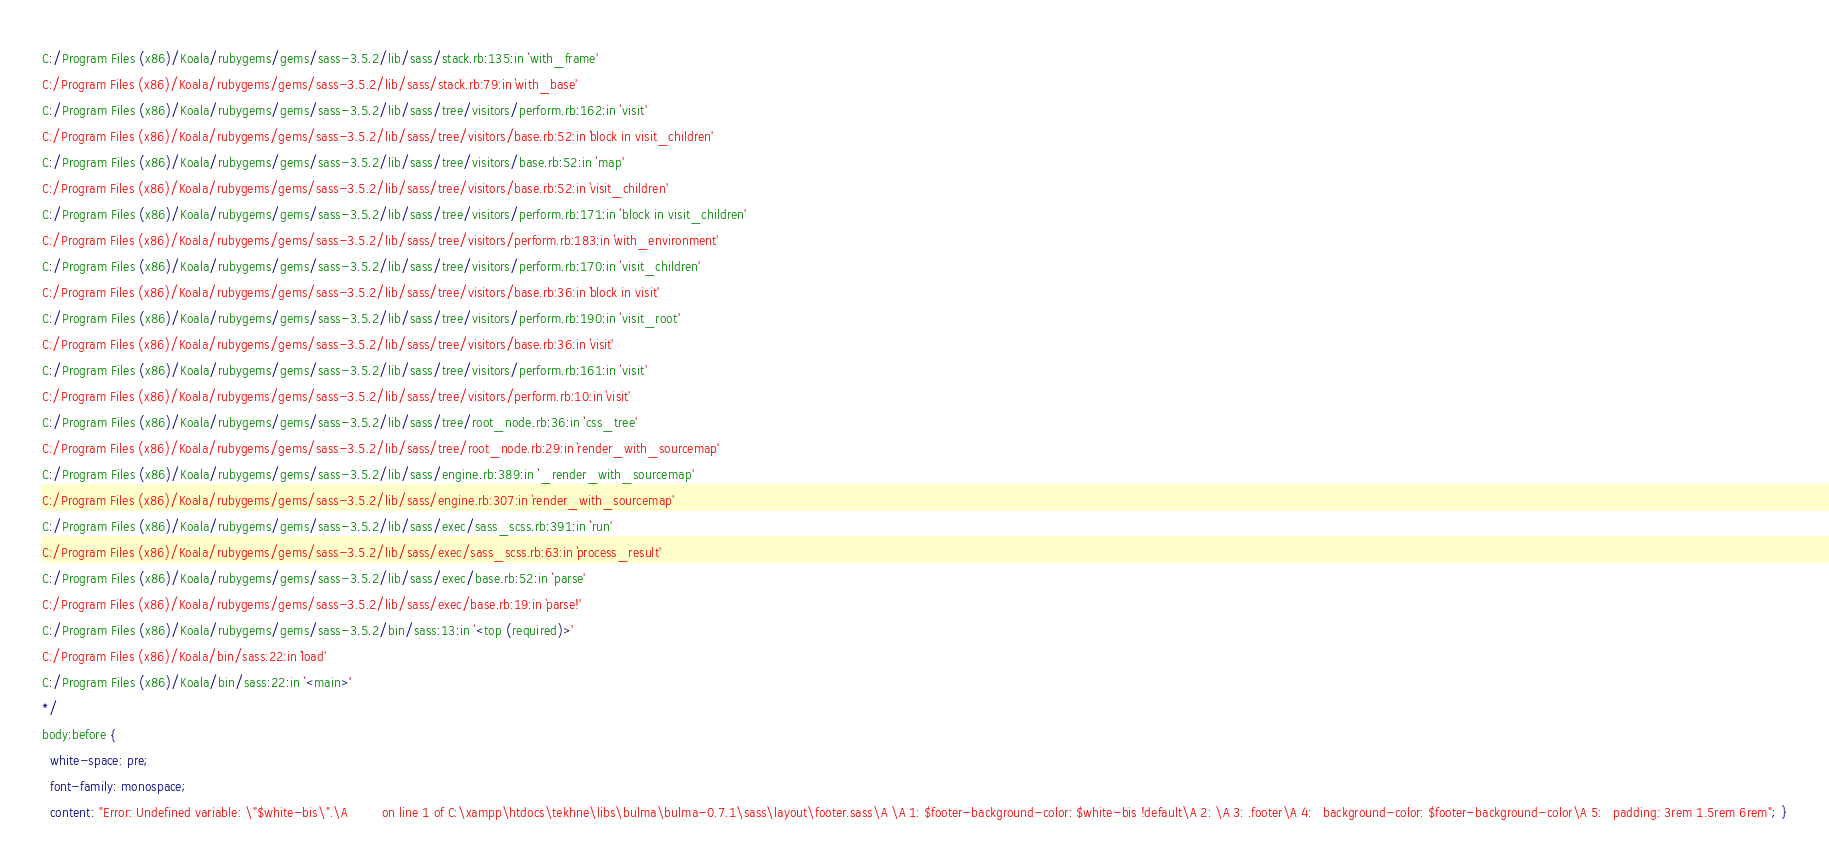Convert code to text. <code><loc_0><loc_0><loc_500><loc_500><_CSS_>C:/Program Files (x86)/Koala/rubygems/gems/sass-3.5.2/lib/sass/stack.rb:135:in `with_frame'
C:/Program Files (x86)/Koala/rubygems/gems/sass-3.5.2/lib/sass/stack.rb:79:in `with_base'
C:/Program Files (x86)/Koala/rubygems/gems/sass-3.5.2/lib/sass/tree/visitors/perform.rb:162:in `visit'
C:/Program Files (x86)/Koala/rubygems/gems/sass-3.5.2/lib/sass/tree/visitors/base.rb:52:in `block in visit_children'
C:/Program Files (x86)/Koala/rubygems/gems/sass-3.5.2/lib/sass/tree/visitors/base.rb:52:in `map'
C:/Program Files (x86)/Koala/rubygems/gems/sass-3.5.2/lib/sass/tree/visitors/base.rb:52:in `visit_children'
C:/Program Files (x86)/Koala/rubygems/gems/sass-3.5.2/lib/sass/tree/visitors/perform.rb:171:in `block in visit_children'
C:/Program Files (x86)/Koala/rubygems/gems/sass-3.5.2/lib/sass/tree/visitors/perform.rb:183:in `with_environment'
C:/Program Files (x86)/Koala/rubygems/gems/sass-3.5.2/lib/sass/tree/visitors/perform.rb:170:in `visit_children'
C:/Program Files (x86)/Koala/rubygems/gems/sass-3.5.2/lib/sass/tree/visitors/base.rb:36:in `block in visit'
C:/Program Files (x86)/Koala/rubygems/gems/sass-3.5.2/lib/sass/tree/visitors/perform.rb:190:in `visit_root'
C:/Program Files (x86)/Koala/rubygems/gems/sass-3.5.2/lib/sass/tree/visitors/base.rb:36:in `visit'
C:/Program Files (x86)/Koala/rubygems/gems/sass-3.5.2/lib/sass/tree/visitors/perform.rb:161:in `visit'
C:/Program Files (x86)/Koala/rubygems/gems/sass-3.5.2/lib/sass/tree/visitors/perform.rb:10:in `visit'
C:/Program Files (x86)/Koala/rubygems/gems/sass-3.5.2/lib/sass/tree/root_node.rb:36:in `css_tree'
C:/Program Files (x86)/Koala/rubygems/gems/sass-3.5.2/lib/sass/tree/root_node.rb:29:in `render_with_sourcemap'
C:/Program Files (x86)/Koala/rubygems/gems/sass-3.5.2/lib/sass/engine.rb:389:in `_render_with_sourcemap'
C:/Program Files (x86)/Koala/rubygems/gems/sass-3.5.2/lib/sass/engine.rb:307:in `render_with_sourcemap'
C:/Program Files (x86)/Koala/rubygems/gems/sass-3.5.2/lib/sass/exec/sass_scss.rb:391:in `run'
C:/Program Files (x86)/Koala/rubygems/gems/sass-3.5.2/lib/sass/exec/sass_scss.rb:63:in `process_result'
C:/Program Files (x86)/Koala/rubygems/gems/sass-3.5.2/lib/sass/exec/base.rb:52:in `parse'
C:/Program Files (x86)/Koala/rubygems/gems/sass-3.5.2/lib/sass/exec/base.rb:19:in `parse!'
C:/Program Files (x86)/Koala/rubygems/gems/sass-3.5.2/bin/sass:13:in `<top (required)>'
C:/Program Files (x86)/Koala/bin/sass:22:in `load'
C:/Program Files (x86)/Koala/bin/sass:22:in `<main>'
*/
body:before {
  white-space: pre;
  font-family: monospace;
  content: "Error: Undefined variable: \"$white-bis\".\A         on line 1 of C:\xampp\htdocs\tekhne\libs\bulma\bulma-0.7.1\sass\layout\footer.sass\A \A 1: $footer-background-color: $white-bis !default\A 2: \A 3: .footer\A 4:   background-color: $footer-background-color\A 5:   padding: 3rem 1.5rem 6rem"; }
</code> 